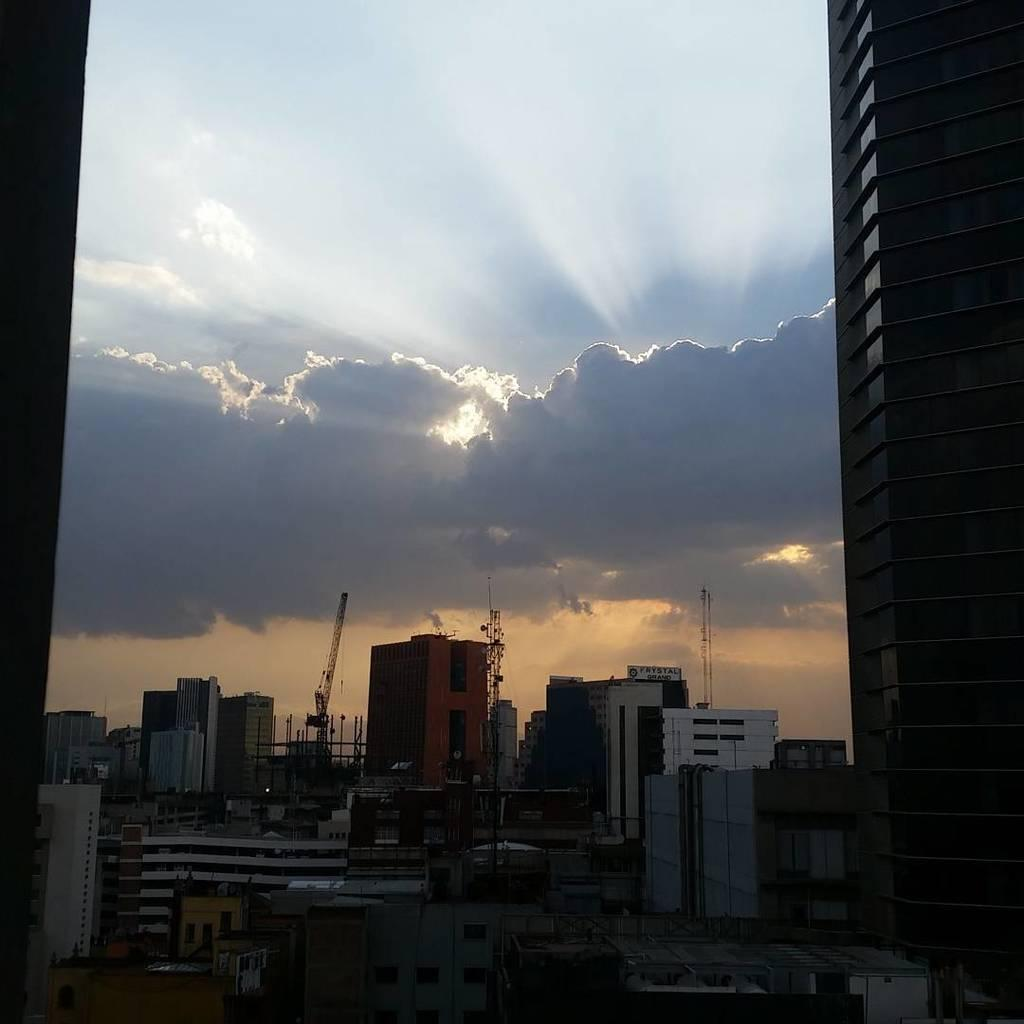What type of structures can be seen in the image? There are buildings in the image. What feature of the buildings is visible in the image? There are windows visible in the image. What construction equipment can be seen in the image? There are cranes in the image. What is the color of the sky in the image? The sky is blue and white in color. How many jellyfish can be seen swimming in the windows of the buildings in the image? There are no jellyfish present in the image; it features buildings with windows and cranes. What type of window is used in the buildings in the image? The type of window is not specified in the image, but windows are visible in the buildings. 